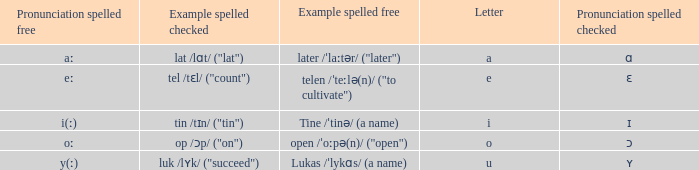What is Pronunciation Spelled Free, when Pronunciation Spelled Checked is "ʏ"? Y(ː). Write the full table. {'header': ['Pronunciation spelled free', 'Example spelled checked', 'Example spelled free', 'Letter', 'Pronunciation spelled checked'], 'rows': [['aː', 'lat /lɑt/ ("lat")', 'later /ˈlaːtər/ ("later")', 'a', 'ɑ'], ['eː', 'tel /tɛl/ ("count")', 'telen /ˈteːlə(n)/ ("to cultivate")', 'e', 'ɛ'], ['i(ː)', 'tin /tɪn/ ("tin")', 'Tine /ˈtinə/ (a name)', 'i', 'ɪ'], ['oː', 'op /ɔp/ ("on")', 'open /ˈoːpə(n)/ ("open")', 'o', 'ɔ'], ['y(ː)', 'luk /lʏk/ ("succeed")', 'Lukas /ˈlykɑs/ (a name)', 'u', 'ʏ']]} 